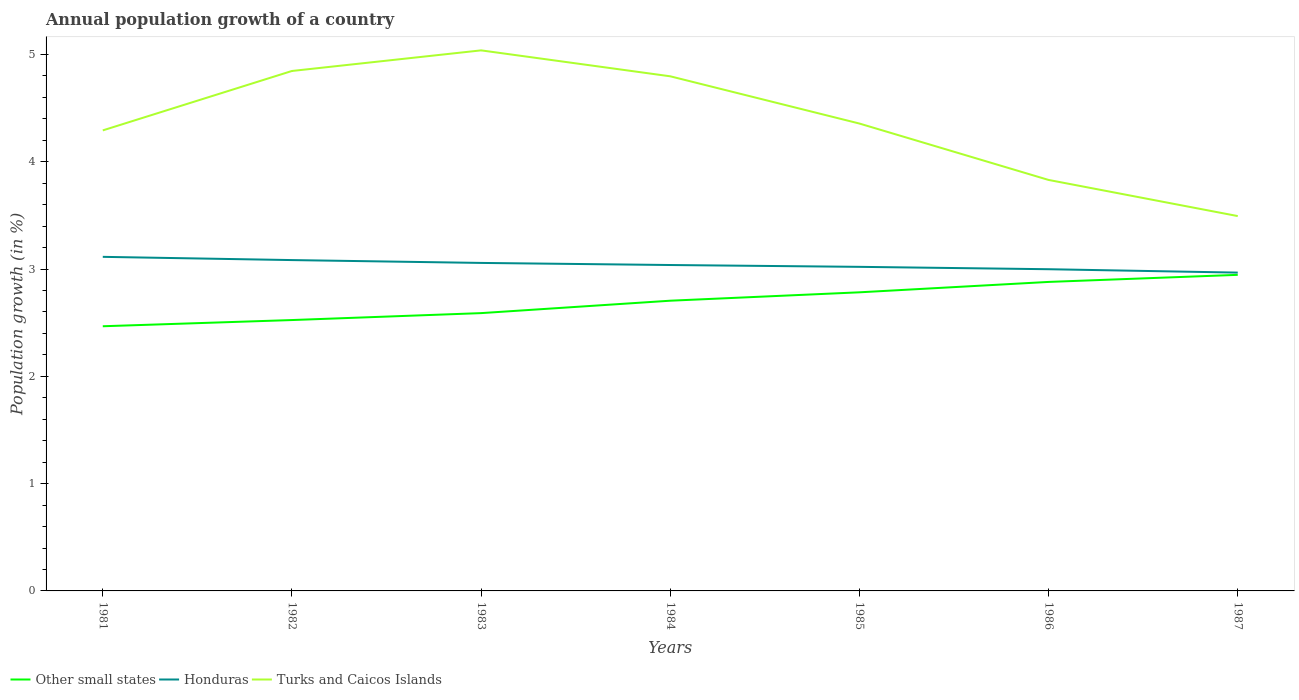How many different coloured lines are there?
Offer a very short reply. 3. Across all years, what is the maximum annual population growth in Honduras?
Your answer should be very brief. 2.97. In which year was the annual population growth in Turks and Caicos Islands maximum?
Your answer should be very brief. 1987. What is the total annual population growth in Honduras in the graph?
Offer a terse response. 0.03. What is the difference between the highest and the second highest annual population growth in Turks and Caicos Islands?
Offer a very short reply. 1.54. What is the difference between the highest and the lowest annual population growth in Other small states?
Your answer should be compact. 4. Is the annual population growth in Turks and Caicos Islands strictly greater than the annual population growth in Honduras over the years?
Provide a short and direct response. No. Are the values on the major ticks of Y-axis written in scientific E-notation?
Your response must be concise. No. Where does the legend appear in the graph?
Your response must be concise. Bottom left. How many legend labels are there?
Offer a terse response. 3. How are the legend labels stacked?
Provide a succinct answer. Horizontal. What is the title of the graph?
Provide a succinct answer. Annual population growth of a country. What is the label or title of the Y-axis?
Provide a short and direct response. Population growth (in %). What is the Population growth (in %) of Other small states in 1981?
Provide a succinct answer. 2.47. What is the Population growth (in %) of Honduras in 1981?
Provide a succinct answer. 3.11. What is the Population growth (in %) in Turks and Caicos Islands in 1981?
Offer a terse response. 4.29. What is the Population growth (in %) of Other small states in 1982?
Make the answer very short. 2.52. What is the Population growth (in %) of Honduras in 1982?
Give a very brief answer. 3.08. What is the Population growth (in %) in Turks and Caicos Islands in 1982?
Give a very brief answer. 4.85. What is the Population growth (in %) in Other small states in 1983?
Your response must be concise. 2.59. What is the Population growth (in %) of Honduras in 1983?
Your response must be concise. 3.06. What is the Population growth (in %) of Turks and Caicos Islands in 1983?
Your answer should be compact. 5.04. What is the Population growth (in %) of Other small states in 1984?
Give a very brief answer. 2.7. What is the Population growth (in %) of Honduras in 1984?
Ensure brevity in your answer.  3.04. What is the Population growth (in %) of Turks and Caicos Islands in 1984?
Your response must be concise. 4.8. What is the Population growth (in %) in Other small states in 1985?
Keep it short and to the point. 2.78. What is the Population growth (in %) in Honduras in 1985?
Offer a very short reply. 3.02. What is the Population growth (in %) of Turks and Caicos Islands in 1985?
Provide a succinct answer. 4.36. What is the Population growth (in %) in Other small states in 1986?
Give a very brief answer. 2.88. What is the Population growth (in %) of Honduras in 1986?
Your response must be concise. 3. What is the Population growth (in %) of Turks and Caicos Islands in 1986?
Offer a very short reply. 3.83. What is the Population growth (in %) of Other small states in 1987?
Your answer should be compact. 2.95. What is the Population growth (in %) of Honduras in 1987?
Your answer should be compact. 2.97. What is the Population growth (in %) of Turks and Caicos Islands in 1987?
Offer a very short reply. 3.49. Across all years, what is the maximum Population growth (in %) of Other small states?
Keep it short and to the point. 2.95. Across all years, what is the maximum Population growth (in %) of Honduras?
Keep it short and to the point. 3.11. Across all years, what is the maximum Population growth (in %) of Turks and Caicos Islands?
Your answer should be very brief. 5.04. Across all years, what is the minimum Population growth (in %) of Other small states?
Your answer should be very brief. 2.47. Across all years, what is the minimum Population growth (in %) of Honduras?
Give a very brief answer. 2.97. Across all years, what is the minimum Population growth (in %) in Turks and Caicos Islands?
Your answer should be compact. 3.49. What is the total Population growth (in %) in Other small states in the graph?
Your response must be concise. 18.89. What is the total Population growth (in %) in Honduras in the graph?
Your answer should be very brief. 21.28. What is the total Population growth (in %) in Turks and Caicos Islands in the graph?
Offer a very short reply. 30.65. What is the difference between the Population growth (in %) of Other small states in 1981 and that in 1982?
Give a very brief answer. -0.06. What is the difference between the Population growth (in %) of Honduras in 1981 and that in 1982?
Offer a very short reply. 0.03. What is the difference between the Population growth (in %) of Turks and Caicos Islands in 1981 and that in 1982?
Ensure brevity in your answer.  -0.55. What is the difference between the Population growth (in %) of Other small states in 1981 and that in 1983?
Your response must be concise. -0.12. What is the difference between the Population growth (in %) of Honduras in 1981 and that in 1983?
Your answer should be very brief. 0.06. What is the difference between the Population growth (in %) in Turks and Caicos Islands in 1981 and that in 1983?
Make the answer very short. -0.75. What is the difference between the Population growth (in %) in Other small states in 1981 and that in 1984?
Your answer should be very brief. -0.24. What is the difference between the Population growth (in %) of Honduras in 1981 and that in 1984?
Provide a succinct answer. 0.08. What is the difference between the Population growth (in %) in Turks and Caicos Islands in 1981 and that in 1984?
Give a very brief answer. -0.5. What is the difference between the Population growth (in %) in Other small states in 1981 and that in 1985?
Provide a short and direct response. -0.32. What is the difference between the Population growth (in %) in Honduras in 1981 and that in 1985?
Keep it short and to the point. 0.09. What is the difference between the Population growth (in %) of Turks and Caicos Islands in 1981 and that in 1985?
Provide a succinct answer. -0.06. What is the difference between the Population growth (in %) in Other small states in 1981 and that in 1986?
Make the answer very short. -0.41. What is the difference between the Population growth (in %) in Honduras in 1981 and that in 1986?
Give a very brief answer. 0.12. What is the difference between the Population growth (in %) in Turks and Caicos Islands in 1981 and that in 1986?
Keep it short and to the point. 0.46. What is the difference between the Population growth (in %) of Other small states in 1981 and that in 1987?
Your answer should be compact. -0.48. What is the difference between the Population growth (in %) of Honduras in 1981 and that in 1987?
Your answer should be very brief. 0.15. What is the difference between the Population growth (in %) of Turks and Caicos Islands in 1981 and that in 1987?
Provide a short and direct response. 0.8. What is the difference between the Population growth (in %) in Other small states in 1982 and that in 1983?
Keep it short and to the point. -0.06. What is the difference between the Population growth (in %) in Honduras in 1982 and that in 1983?
Your answer should be compact. 0.03. What is the difference between the Population growth (in %) in Turks and Caicos Islands in 1982 and that in 1983?
Your answer should be compact. -0.19. What is the difference between the Population growth (in %) of Other small states in 1982 and that in 1984?
Provide a succinct answer. -0.18. What is the difference between the Population growth (in %) in Honduras in 1982 and that in 1984?
Provide a short and direct response. 0.05. What is the difference between the Population growth (in %) of Turks and Caicos Islands in 1982 and that in 1984?
Keep it short and to the point. 0.05. What is the difference between the Population growth (in %) of Other small states in 1982 and that in 1985?
Provide a succinct answer. -0.26. What is the difference between the Population growth (in %) in Honduras in 1982 and that in 1985?
Ensure brevity in your answer.  0.06. What is the difference between the Population growth (in %) of Turks and Caicos Islands in 1982 and that in 1985?
Give a very brief answer. 0.49. What is the difference between the Population growth (in %) of Other small states in 1982 and that in 1986?
Your answer should be very brief. -0.36. What is the difference between the Population growth (in %) of Honduras in 1982 and that in 1986?
Provide a succinct answer. 0.09. What is the difference between the Population growth (in %) in Turks and Caicos Islands in 1982 and that in 1986?
Make the answer very short. 1.02. What is the difference between the Population growth (in %) of Other small states in 1982 and that in 1987?
Provide a succinct answer. -0.42. What is the difference between the Population growth (in %) in Honduras in 1982 and that in 1987?
Ensure brevity in your answer.  0.12. What is the difference between the Population growth (in %) in Turks and Caicos Islands in 1982 and that in 1987?
Your answer should be very brief. 1.35. What is the difference between the Population growth (in %) in Other small states in 1983 and that in 1984?
Give a very brief answer. -0.12. What is the difference between the Population growth (in %) in Honduras in 1983 and that in 1984?
Your answer should be very brief. 0.02. What is the difference between the Population growth (in %) of Turks and Caicos Islands in 1983 and that in 1984?
Provide a short and direct response. 0.24. What is the difference between the Population growth (in %) of Other small states in 1983 and that in 1985?
Give a very brief answer. -0.19. What is the difference between the Population growth (in %) in Honduras in 1983 and that in 1985?
Ensure brevity in your answer.  0.04. What is the difference between the Population growth (in %) in Turks and Caicos Islands in 1983 and that in 1985?
Keep it short and to the point. 0.68. What is the difference between the Population growth (in %) of Other small states in 1983 and that in 1986?
Your answer should be very brief. -0.29. What is the difference between the Population growth (in %) in Honduras in 1983 and that in 1986?
Your answer should be very brief. 0.06. What is the difference between the Population growth (in %) of Turks and Caicos Islands in 1983 and that in 1986?
Offer a terse response. 1.21. What is the difference between the Population growth (in %) of Other small states in 1983 and that in 1987?
Provide a short and direct response. -0.36. What is the difference between the Population growth (in %) of Honduras in 1983 and that in 1987?
Keep it short and to the point. 0.09. What is the difference between the Population growth (in %) of Turks and Caicos Islands in 1983 and that in 1987?
Keep it short and to the point. 1.54. What is the difference between the Population growth (in %) of Other small states in 1984 and that in 1985?
Ensure brevity in your answer.  -0.08. What is the difference between the Population growth (in %) in Honduras in 1984 and that in 1985?
Your answer should be very brief. 0.02. What is the difference between the Population growth (in %) of Turks and Caicos Islands in 1984 and that in 1985?
Give a very brief answer. 0.44. What is the difference between the Population growth (in %) of Other small states in 1984 and that in 1986?
Provide a short and direct response. -0.17. What is the difference between the Population growth (in %) in Honduras in 1984 and that in 1986?
Make the answer very short. 0.04. What is the difference between the Population growth (in %) of Turks and Caicos Islands in 1984 and that in 1986?
Your answer should be compact. 0.97. What is the difference between the Population growth (in %) of Other small states in 1984 and that in 1987?
Provide a succinct answer. -0.24. What is the difference between the Population growth (in %) in Honduras in 1984 and that in 1987?
Your answer should be compact. 0.07. What is the difference between the Population growth (in %) of Turks and Caicos Islands in 1984 and that in 1987?
Keep it short and to the point. 1.3. What is the difference between the Population growth (in %) of Other small states in 1985 and that in 1986?
Offer a terse response. -0.1. What is the difference between the Population growth (in %) in Honduras in 1985 and that in 1986?
Offer a very short reply. 0.02. What is the difference between the Population growth (in %) in Turks and Caicos Islands in 1985 and that in 1986?
Your answer should be very brief. 0.53. What is the difference between the Population growth (in %) of Other small states in 1985 and that in 1987?
Make the answer very short. -0.16. What is the difference between the Population growth (in %) of Honduras in 1985 and that in 1987?
Your answer should be very brief. 0.05. What is the difference between the Population growth (in %) in Turks and Caicos Islands in 1985 and that in 1987?
Your response must be concise. 0.86. What is the difference between the Population growth (in %) of Other small states in 1986 and that in 1987?
Make the answer very short. -0.07. What is the difference between the Population growth (in %) in Honduras in 1986 and that in 1987?
Keep it short and to the point. 0.03. What is the difference between the Population growth (in %) in Turks and Caicos Islands in 1986 and that in 1987?
Your answer should be very brief. 0.34. What is the difference between the Population growth (in %) in Other small states in 1981 and the Population growth (in %) in Honduras in 1982?
Provide a succinct answer. -0.62. What is the difference between the Population growth (in %) in Other small states in 1981 and the Population growth (in %) in Turks and Caicos Islands in 1982?
Provide a succinct answer. -2.38. What is the difference between the Population growth (in %) in Honduras in 1981 and the Population growth (in %) in Turks and Caicos Islands in 1982?
Ensure brevity in your answer.  -1.73. What is the difference between the Population growth (in %) in Other small states in 1981 and the Population growth (in %) in Honduras in 1983?
Ensure brevity in your answer.  -0.59. What is the difference between the Population growth (in %) of Other small states in 1981 and the Population growth (in %) of Turks and Caicos Islands in 1983?
Your answer should be compact. -2.57. What is the difference between the Population growth (in %) in Honduras in 1981 and the Population growth (in %) in Turks and Caicos Islands in 1983?
Offer a very short reply. -1.92. What is the difference between the Population growth (in %) in Other small states in 1981 and the Population growth (in %) in Honduras in 1984?
Your response must be concise. -0.57. What is the difference between the Population growth (in %) of Other small states in 1981 and the Population growth (in %) of Turks and Caicos Islands in 1984?
Offer a terse response. -2.33. What is the difference between the Population growth (in %) in Honduras in 1981 and the Population growth (in %) in Turks and Caicos Islands in 1984?
Offer a terse response. -1.68. What is the difference between the Population growth (in %) in Other small states in 1981 and the Population growth (in %) in Honduras in 1985?
Your answer should be very brief. -0.55. What is the difference between the Population growth (in %) in Other small states in 1981 and the Population growth (in %) in Turks and Caicos Islands in 1985?
Provide a succinct answer. -1.89. What is the difference between the Population growth (in %) in Honduras in 1981 and the Population growth (in %) in Turks and Caicos Islands in 1985?
Provide a short and direct response. -1.24. What is the difference between the Population growth (in %) of Other small states in 1981 and the Population growth (in %) of Honduras in 1986?
Ensure brevity in your answer.  -0.53. What is the difference between the Population growth (in %) of Other small states in 1981 and the Population growth (in %) of Turks and Caicos Islands in 1986?
Make the answer very short. -1.36. What is the difference between the Population growth (in %) in Honduras in 1981 and the Population growth (in %) in Turks and Caicos Islands in 1986?
Provide a succinct answer. -0.72. What is the difference between the Population growth (in %) of Other small states in 1981 and the Population growth (in %) of Honduras in 1987?
Give a very brief answer. -0.5. What is the difference between the Population growth (in %) in Other small states in 1981 and the Population growth (in %) in Turks and Caicos Islands in 1987?
Your response must be concise. -1.03. What is the difference between the Population growth (in %) of Honduras in 1981 and the Population growth (in %) of Turks and Caicos Islands in 1987?
Ensure brevity in your answer.  -0.38. What is the difference between the Population growth (in %) in Other small states in 1982 and the Population growth (in %) in Honduras in 1983?
Your response must be concise. -0.53. What is the difference between the Population growth (in %) of Other small states in 1982 and the Population growth (in %) of Turks and Caicos Islands in 1983?
Your answer should be compact. -2.51. What is the difference between the Population growth (in %) of Honduras in 1982 and the Population growth (in %) of Turks and Caicos Islands in 1983?
Your answer should be compact. -1.95. What is the difference between the Population growth (in %) of Other small states in 1982 and the Population growth (in %) of Honduras in 1984?
Your answer should be very brief. -0.51. What is the difference between the Population growth (in %) of Other small states in 1982 and the Population growth (in %) of Turks and Caicos Islands in 1984?
Provide a succinct answer. -2.27. What is the difference between the Population growth (in %) of Honduras in 1982 and the Population growth (in %) of Turks and Caicos Islands in 1984?
Provide a short and direct response. -1.71. What is the difference between the Population growth (in %) of Other small states in 1982 and the Population growth (in %) of Honduras in 1985?
Provide a succinct answer. -0.5. What is the difference between the Population growth (in %) in Other small states in 1982 and the Population growth (in %) in Turks and Caicos Islands in 1985?
Provide a succinct answer. -1.83. What is the difference between the Population growth (in %) in Honduras in 1982 and the Population growth (in %) in Turks and Caicos Islands in 1985?
Offer a terse response. -1.27. What is the difference between the Population growth (in %) in Other small states in 1982 and the Population growth (in %) in Honduras in 1986?
Give a very brief answer. -0.47. What is the difference between the Population growth (in %) in Other small states in 1982 and the Population growth (in %) in Turks and Caicos Islands in 1986?
Make the answer very short. -1.31. What is the difference between the Population growth (in %) of Honduras in 1982 and the Population growth (in %) of Turks and Caicos Islands in 1986?
Make the answer very short. -0.75. What is the difference between the Population growth (in %) of Other small states in 1982 and the Population growth (in %) of Honduras in 1987?
Offer a terse response. -0.44. What is the difference between the Population growth (in %) in Other small states in 1982 and the Population growth (in %) in Turks and Caicos Islands in 1987?
Offer a terse response. -0.97. What is the difference between the Population growth (in %) in Honduras in 1982 and the Population growth (in %) in Turks and Caicos Islands in 1987?
Provide a short and direct response. -0.41. What is the difference between the Population growth (in %) of Other small states in 1983 and the Population growth (in %) of Honduras in 1984?
Offer a terse response. -0.45. What is the difference between the Population growth (in %) of Other small states in 1983 and the Population growth (in %) of Turks and Caicos Islands in 1984?
Give a very brief answer. -2.21. What is the difference between the Population growth (in %) of Honduras in 1983 and the Population growth (in %) of Turks and Caicos Islands in 1984?
Your response must be concise. -1.74. What is the difference between the Population growth (in %) of Other small states in 1983 and the Population growth (in %) of Honduras in 1985?
Your answer should be compact. -0.43. What is the difference between the Population growth (in %) in Other small states in 1983 and the Population growth (in %) in Turks and Caicos Islands in 1985?
Ensure brevity in your answer.  -1.77. What is the difference between the Population growth (in %) in Honduras in 1983 and the Population growth (in %) in Turks and Caicos Islands in 1985?
Your answer should be very brief. -1.3. What is the difference between the Population growth (in %) of Other small states in 1983 and the Population growth (in %) of Honduras in 1986?
Give a very brief answer. -0.41. What is the difference between the Population growth (in %) of Other small states in 1983 and the Population growth (in %) of Turks and Caicos Islands in 1986?
Provide a succinct answer. -1.24. What is the difference between the Population growth (in %) in Honduras in 1983 and the Population growth (in %) in Turks and Caicos Islands in 1986?
Offer a terse response. -0.77. What is the difference between the Population growth (in %) in Other small states in 1983 and the Population growth (in %) in Honduras in 1987?
Provide a succinct answer. -0.38. What is the difference between the Population growth (in %) in Other small states in 1983 and the Population growth (in %) in Turks and Caicos Islands in 1987?
Your response must be concise. -0.9. What is the difference between the Population growth (in %) in Honduras in 1983 and the Population growth (in %) in Turks and Caicos Islands in 1987?
Make the answer very short. -0.44. What is the difference between the Population growth (in %) in Other small states in 1984 and the Population growth (in %) in Honduras in 1985?
Give a very brief answer. -0.32. What is the difference between the Population growth (in %) of Other small states in 1984 and the Population growth (in %) of Turks and Caicos Islands in 1985?
Your answer should be very brief. -1.65. What is the difference between the Population growth (in %) of Honduras in 1984 and the Population growth (in %) of Turks and Caicos Islands in 1985?
Provide a short and direct response. -1.32. What is the difference between the Population growth (in %) of Other small states in 1984 and the Population growth (in %) of Honduras in 1986?
Make the answer very short. -0.29. What is the difference between the Population growth (in %) of Other small states in 1984 and the Population growth (in %) of Turks and Caicos Islands in 1986?
Give a very brief answer. -1.13. What is the difference between the Population growth (in %) of Honduras in 1984 and the Population growth (in %) of Turks and Caicos Islands in 1986?
Keep it short and to the point. -0.79. What is the difference between the Population growth (in %) of Other small states in 1984 and the Population growth (in %) of Honduras in 1987?
Offer a very short reply. -0.26. What is the difference between the Population growth (in %) of Other small states in 1984 and the Population growth (in %) of Turks and Caicos Islands in 1987?
Your response must be concise. -0.79. What is the difference between the Population growth (in %) in Honduras in 1984 and the Population growth (in %) in Turks and Caicos Islands in 1987?
Your response must be concise. -0.46. What is the difference between the Population growth (in %) in Other small states in 1985 and the Population growth (in %) in Honduras in 1986?
Your response must be concise. -0.22. What is the difference between the Population growth (in %) of Other small states in 1985 and the Population growth (in %) of Turks and Caicos Islands in 1986?
Your answer should be very brief. -1.05. What is the difference between the Population growth (in %) in Honduras in 1985 and the Population growth (in %) in Turks and Caicos Islands in 1986?
Provide a short and direct response. -0.81. What is the difference between the Population growth (in %) of Other small states in 1985 and the Population growth (in %) of Honduras in 1987?
Give a very brief answer. -0.18. What is the difference between the Population growth (in %) in Other small states in 1985 and the Population growth (in %) in Turks and Caicos Islands in 1987?
Provide a succinct answer. -0.71. What is the difference between the Population growth (in %) in Honduras in 1985 and the Population growth (in %) in Turks and Caicos Islands in 1987?
Give a very brief answer. -0.47. What is the difference between the Population growth (in %) in Other small states in 1986 and the Population growth (in %) in Honduras in 1987?
Give a very brief answer. -0.09. What is the difference between the Population growth (in %) of Other small states in 1986 and the Population growth (in %) of Turks and Caicos Islands in 1987?
Offer a very short reply. -0.61. What is the difference between the Population growth (in %) in Honduras in 1986 and the Population growth (in %) in Turks and Caicos Islands in 1987?
Provide a short and direct response. -0.5. What is the average Population growth (in %) in Other small states per year?
Provide a succinct answer. 2.7. What is the average Population growth (in %) in Honduras per year?
Ensure brevity in your answer.  3.04. What is the average Population growth (in %) of Turks and Caicos Islands per year?
Offer a very short reply. 4.38. In the year 1981, what is the difference between the Population growth (in %) in Other small states and Population growth (in %) in Honduras?
Your response must be concise. -0.65. In the year 1981, what is the difference between the Population growth (in %) in Other small states and Population growth (in %) in Turks and Caicos Islands?
Provide a succinct answer. -1.83. In the year 1981, what is the difference between the Population growth (in %) of Honduras and Population growth (in %) of Turks and Caicos Islands?
Offer a terse response. -1.18. In the year 1982, what is the difference between the Population growth (in %) of Other small states and Population growth (in %) of Honduras?
Offer a terse response. -0.56. In the year 1982, what is the difference between the Population growth (in %) in Other small states and Population growth (in %) in Turks and Caicos Islands?
Your answer should be very brief. -2.32. In the year 1982, what is the difference between the Population growth (in %) of Honduras and Population growth (in %) of Turks and Caicos Islands?
Your answer should be compact. -1.76. In the year 1983, what is the difference between the Population growth (in %) of Other small states and Population growth (in %) of Honduras?
Keep it short and to the point. -0.47. In the year 1983, what is the difference between the Population growth (in %) of Other small states and Population growth (in %) of Turks and Caicos Islands?
Make the answer very short. -2.45. In the year 1983, what is the difference between the Population growth (in %) in Honduras and Population growth (in %) in Turks and Caicos Islands?
Your response must be concise. -1.98. In the year 1984, what is the difference between the Population growth (in %) of Other small states and Population growth (in %) of Honduras?
Your response must be concise. -0.33. In the year 1984, what is the difference between the Population growth (in %) in Other small states and Population growth (in %) in Turks and Caicos Islands?
Your answer should be compact. -2.09. In the year 1984, what is the difference between the Population growth (in %) of Honduras and Population growth (in %) of Turks and Caicos Islands?
Keep it short and to the point. -1.76. In the year 1985, what is the difference between the Population growth (in %) of Other small states and Population growth (in %) of Honduras?
Offer a terse response. -0.24. In the year 1985, what is the difference between the Population growth (in %) in Other small states and Population growth (in %) in Turks and Caicos Islands?
Make the answer very short. -1.57. In the year 1985, what is the difference between the Population growth (in %) of Honduras and Population growth (in %) of Turks and Caicos Islands?
Your response must be concise. -1.34. In the year 1986, what is the difference between the Population growth (in %) of Other small states and Population growth (in %) of Honduras?
Make the answer very short. -0.12. In the year 1986, what is the difference between the Population growth (in %) in Other small states and Population growth (in %) in Turks and Caicos Islands?
Make the answer very short. -0.95. In the year 1986, what is the difference between the Population growth (in %) in Honduras and Population growth (in %) in Turks and Caicos Islands?
Your answer should be compact. -0.83. In the year 1987, what is the difference between the Population growth (in %) of Other small states and Population growth (in %) of Honduras?
Give a very brief answer. -0.02. In the year 1987, what is the difference between the Population growth (in %) in Other small states and Population growth (in %) in Turks and Caicos Islands?
Your answer should be compact. -0.55. In the year 1987, what is the difference between the Population growth (in %) of Honduras and Population growth (in %) of Turks and Caicos Islands?
Provide a succinct answer. -0.53. What is the ratio of the Population growth (in %) of Other small states in 1981 to that in 1982?
Your response must be concise. 0.98. What is the ratio of the Population growth (in %) of Honduras in 1981 to that in 1982?
Ensure brevity in your answer.  1.01. What is the ratio of the Population growth (in %) of Turks and Caicos Islands in 1981 to that in 1982?
Give a very brief answer. 0.89. What is the ratio of the Population growth (in %) in Other small states in 1981 to that in 1983?
Your answer should be compact. 0.95. What is the ratio of the Population growth (in %) of Honduras in 1981 to that in 1983?
Offer a very short reply. 1.02. What is the ratio of the Population growth (in %) in Turks and Caicos Islands in 1981 to that in 1983?
Give a very brief answer. 0.85. What is the ratio of the Population growth (in %) of Other small states in 1981 to that in 1984?
Keep it short and to the point. 0.91. What is the ratio of the Population growth (in %) in Honduras in 1981 to that in 1984?
Your answer should be compact. 1.03. What is the ratio of the Population growth (in %) of Turks and Caicos Islands in 1981 to that in 1984?
Ensure brevity in your answer.  0.89. What is the ratio of the Population growth (in %) in Other small states in 1981 to that in 1985?
Offer a terse response. 0.89. What is the ratio of the Population growth (in %) of Honduras in 1981 to that in 1985?
Give a very brief answer. 1.03. What is the ratio of the Population growth (in %) in Other small states in 1981 to that in 1986?
Your answer should be very brief. 0.86. What is the ratio of the Population growth (in %) of Turks and Caicos Islands in 1981 to that in 1986?
Provide a succinct answer. 1.12. What is the ratio of the Population growth (in %) of Other small states in 1981 to that in 1987?
Offer a very short reply. 0.84. What is the ratio of the Population growth (in %) of Honduras in 1981 to that in 1987?
Provide a succinct answer. 1.05. What is the ratio of the Population growth (in %) in Turks and Caicos Islands in 1981 to that in 1987?
Provide a succinct answer. 1.23. What is the ratio of the Population growth (in %) in Other small states in 1982 to that in 1983?
Keep it short and to the point. 0.98. What is the ratio of the Population growth (in %) in Honduras in 1982 to that in 1983?
Keep it short and to the point. 1.01. What is the ratio of the Population growth (in %) in Turks and Caicos Islands in 1982 to that in 1983?
Provide a short and direct response. 0.96. What is the ratio of the Population growth (in %) of Other small states in 1982 to that in 1984?
Keep it short and to the point. 0.93. What is the ratio of the Population growth (in %) in Honduras in 1982 to that in 1984?
Offer a terse response. 1.02. What is the ratio of the Population growth (in %) of Turks and Caicos Islands in 1982 to that in 1984?
Your answer should be compact. 1.01. What is the ratio of the Population growth (in %) in Other small states in 1982 to that in 1985?
Offer a terse response. 0.91. What is the ratio of the Population growth (in %) in Honduras in 1982 to that in 1985?
Provide a short and direct response. 1.02. What is the ratio of the Population growth (in %) in Turks and Caicos Islands in 1982 to that in 1985?
Your answer should be compact. 1.11. What is the ratio of the Population growth (in %) in Other small states in 1982 to that in 1986?
Your answer should be compact. 0.88. What is the ratio of the Population growth (in %) in Honduras in 1982 to that in 1986?
Provide a succinct answer. 1.03. What is the ratio of the Population growth (in %) in Turks and Caicos Islands in 1982 to that in 1986?
Make the answer very short. 1.27. What is the ratio of the Population growth (in %) in Other small states in 1982 to that in 1987?
Make the answer very short. 0.86. What is the ratio of the Population growth (in %) of Honduras in 1982 to that in 1987?
Offer a terse response. 1.04. What is the ratio of the Population growth (in %) of Turks and Caicos Islands in 1982 to that in 1987?
Your answer should be very brief. 1.39. What is the ratio of the Population growth (in %) in Other small states in 1983 to that in 1984?
Keep it short and to the point. 0.96. What is the ratio of the Population growth (in %) in Honduras in 1983 to that in 1984?
Make the answer very short. 1.01. What is the ratio of the Population growth (in %) in Turks and Caicos Islands in 1983 to that in 1984?
Offer a very short reply. 1.05. What is the ratio of the Population growth (in %) in Other small states in 1983 to that in 1985?
Make the answer very short. 0.93. What is the ratio of the Population growth (in %) in Honduras in 1983 to that in 1985?
Give a very brief answer. 1.01. What is the ratio of the Population growth (in %) in Turks and Caicos Islands in 1983 to that in 1985?
Give a very brief answer. 1.16. What is the ratio of the Population growth (in %) in Other small states in 1983 to that in 1986?
Give a very brief answer. 0.9. What is the ratio of the Population growth (in %) of Honduras in 1983 to that in 1986?
Your response must be concise. 1.02. What is the ratio of the Population growth (in %) of Turks and Caicos Islands in 1983 to that in 1986?
Offer a very short reply. 1.32. What is the ratio of the Population growth (in %) in Other small states in 1983 to that in 1987?
Provide a short and direct response. 0.88. What is the ratio of the Population growth (in %) in Honduras in 1983 to that in 1987?
Give a very brief answer. 1.03. What is the ratio of the Population growth (in %) in Turks and Caicos Islands in 1983 to that in 1987?
Your answer should be compact. 1.44. What is the ratio of the Population growth (in %) in Other small states in 1984 to that in 1985?
Ensure brevity in your answer.  0.97. What is the ratio of the Population growth (in %) of Honduras in 1984 to that in 1985?
Your answer should be very brief. 1.01. What is the ratio of the Population growth (in %) in Turks and Caicos Islands in 1984 to that in 1985?
Your answer should be very brief. 1.1. What is the ratio of the Population growth (in %) of Other small states in 1984 to that in 1986?
Ensure brevity in your answer.  0.94. What is the ratio of the Population growth (in %) of Honduras in 1984 to that in 1986?
Offer a very short reply. 1.01. What is the ratio of the Population growth (in %) in Turks and Caicos Islands in 1984 to that in 1986?
Your answer should be very brief. 1.25. What is the ratio of the Population growth (in %) in Other small states in 1984 to that in 1987?
Provide a short and direct response. 0.92. What is the ratio of the Population growth (in %) in Honduras in 1984 to that in 1987?
Ensure brevity in your answer.  1.02. What is the ratio of the Population growth (in %) in Turks and Caicos Islands in 1984 to that in 1987?
Offer a very short reply. 1.37. What is the ratio of the Population growth (in %) of Other small states in 1985 to that in 1986?
Provide a short and direct response. 0.97. What is the ratio of the Population growth (in %) of Honduras in 1985 to that in 1986?
Make the answer very short. 1.01. What is the ratio of the Population growth (in %) in Turks and Caicos Islands in 1985 to that in 1986?
Offer a very short reply. 1.14. What is the ratio of the Population growth (in %) in Other small states in 1985 to that in 1987?
Your answer should be compact. 0.94. What is the ratio of the Population growth (in %) of Honduras in 1985 to that in 1987?
Keep it short and to the point. 1.02. What is the ratio of the Population growth (in %) in Turks and Caicos Islands in 1985 to that in 1987?
Provide a short and direct response. 1.25. What is the ratio of the Population growth (in %) in Other small states in 1986 to that in 1987?
Offer a very short reply. 0.98. What is the ratio of the Population growth (in %) of Honduras in 1986 to that in 1987?
Your response must be concise. 1.01. What is the ratio of the Population growth (in %) of Turks and Caicos Islands in 1986 to that in 1987?
Ensure brevity in your answer.  1.1. What is the difference between the highest and the second highest Population growth (in %) of Other small states?
Your answer should be very brief. 0.07. What is the difference between the highest and the second highest Population growth (in %) in Honduras?
Keep it short and to the point. 0.03. What is the difference between the highest and the second highest Population growth (in %) of Turks and Caicos Islands?
Ensure brevity in your answer.  0.19. What is the difference between the highest and the lowest Population growth (in %) in Other small states?
Give a very brief answer. 0.48. What is the difference between the highest and the lowest Population growth (in %) of Honduras?
Your answer should be compact. 0.15. What is the difference between the highest and the lowest Population growth (in %) in Turks and Caicos Islands?
Offer a terse response. 1.54. 